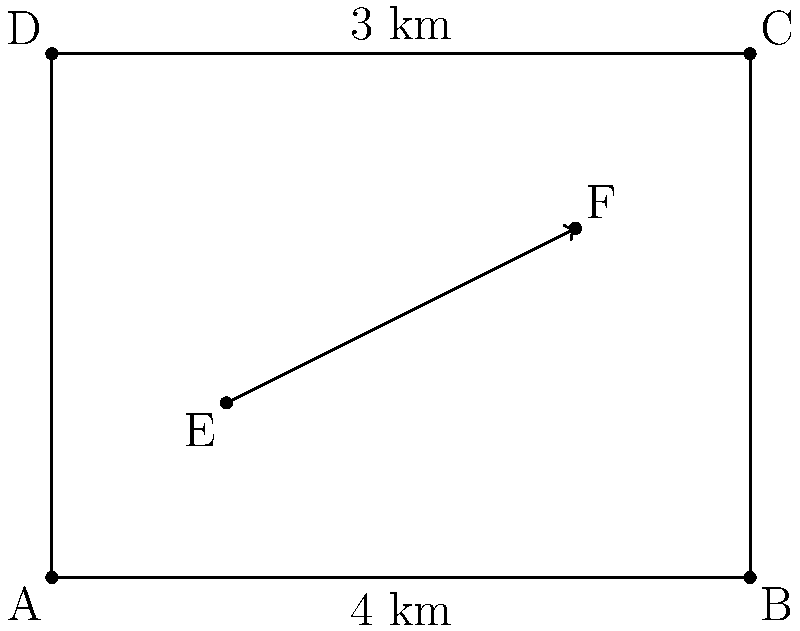In planning emergency evacuation routes for a community, you need to optimize the vector path from point E to point F in the given diagram. If the evacuation speed is 2 km/h, what is the minimum time required to travel from E to F? Round your answer to the nearest minute. To solve this problem, we'll follow these steps:

1) First, we need to find the vector $\vec{EF}$:
   $\vec{EF} = F - E = (3,2) - (1,1) = (2,1)$

2) Calculate the magnitude of $\vec{EF}$ using the Pythagorean theorem:
   $|\vec{EF}| = \sqrt{2^2 + 1^2} = \sqrt{5}$ km

3) Given the evacuation speed of 2 km/h, we can calculate the time using the formula:
   $\text{Time} = \frac{\text{Distance}}{\text{Speed}}$

4) Plugging in our values:
   $\text{Time} = \frac{\sqrt{5}}{2}$ hours

5) Convert this to minutes:
   $\text{Time} = \frac{\sqrt{5}}{2} \times 60 \approx 67.08$ minutes

6) Rounding to the nearest minute:
   $\text{Time} \approx 67$ minutes

This represents the minimum time required to travel from E to F along the optimized vector path.
Answer: 67 minutes 